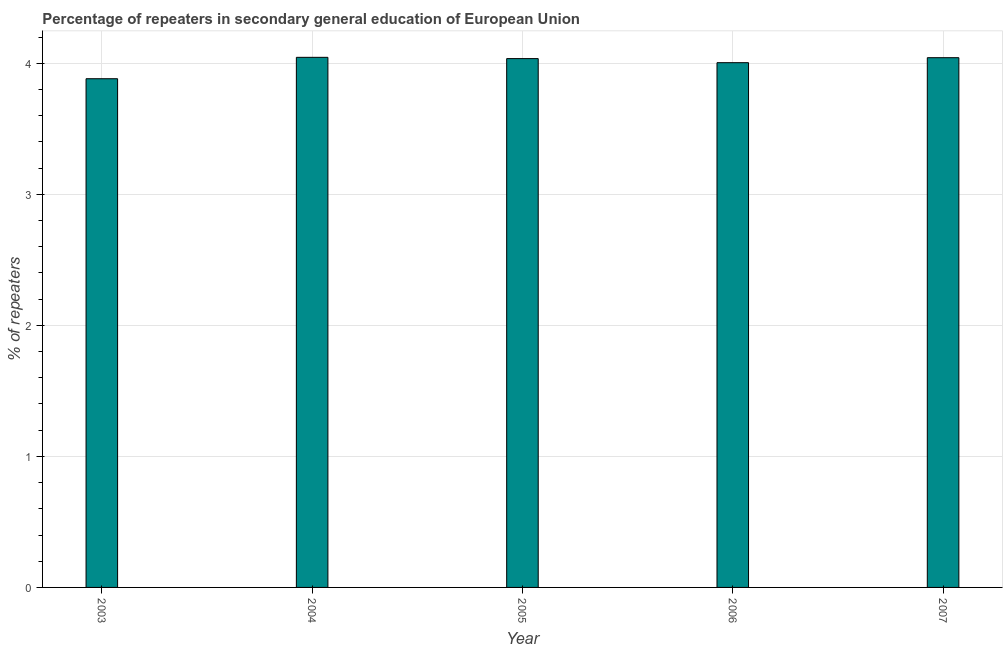What is the title of the graph?
Your answer should be compact. Percentage of repeaters in secondary general education of European Union. What is the label or title of the Y-axis?
Provide a succinct answer. % of repeaters. What is the percentage of repeaters in 2005?
Ensure brevity in your answer.  4.04. Across all years, what is the maximum percentage of repeaters?
Provide a succinct answer. 4.05. Across all years, what is the minimum percentage of repeaters?
Make the answer very short. 3.88. What is the sum of the percentage of repeaters?
Your answer should be very brief. 20.01. What is the difference between the percentage of repeaters in 2004 and 2007?
Offer a terse response. 0. What is the average percentage of repeaters per year?
Offer a very short reply. 4. What is the median percentage of repeaters?
Keep it short and to the point. 4.04. In how many years, is the percentage of repeaters greater than 0.4 %?
Your answer should be very brief. 5. Do a majority of the years between 2006 and 2004 (inclusive) have percentage of repeaters greater than 1.2 %?
Provide a succinct answer. Yes. What is the ratio of the percentage of repeaters in 2003 to that in 2005?
Offer a terse response. 0.96. What is the difference between the highest and the second highest percentage of repeaters?
Provide a short and direct response. 0. What is the difference between the highest and the lowest percentage of repeaters?
Provide a succinct answer. 0.16. How many bars are there?
Ensure brevity in your answer.  5. Are all the bars in the graph horizontal?
Offer a terse response. No. What is the % of repeaters in 2003?
Your response must be concise. 3.88. What is the % of repeaters of 2004?
Provide a short and direct response. 4.05. What is the % of repeaters of 2005?
Offer a terse response. 4.04. What is the % of repeaters of 2006?
Offer a terse response. 4. What is the % of repeaters of 2007?
Keep it short and to the point. 4.04. What is the difference between the % of repeaters in 2003 and 2004?
Keep it short and to the point. -0.16. What is the difference between the % of repeaters in 2003 and 2005?
Provide a short and direct response. -0.15. What is the difference between the % of repeaters in 2003 and 2006?
Offer a terse response. -0.12. What is the difference between the % of repeaters in 2003 and 2007?
Your response must be concise. -0.16. What is the difference between the % of repeaters in 2004 and 2005?
Your answer should be compact. 0.01. What is the difference between the % of repeaters in 2004 and 2006?
Offer a terse response. 0.04. What is the difference between the % of repeaters in 2004 and 2007?
Give a very brief answer. 0. What is the difference between the % of repeaters in 2005 and 2006?
Keep it short and to the point. 0.03. What is the difference between the % of repeaters in 2005 and 2007?
Offer a very short reply. -0.01. What is the difference between the % of repeaters in 2006 and 2007?
Offer a terse response. -0.04. What is the ratio of the % of repeaters in 2003 to that in 2004?
Ensure brevity in your answer.  0.96. What is the ratio of the % of repeaters in 2003 to that in 2006?
Ensure brevity in your answer.  0.97. What is the ratio of the % of repeaters in 2003 to that in 2007?
Give a very brief answer. 0.96. What is the ratio of the % of repeaters in 2004 to that in 2005?
Provide a short and direct response. 1. What is the ratio of the % of repeaters in 2004 to that in 2007?
Provide a succinct answer. 1. What is the ratio of the % of repeaters in 2005 to that in 2007?
Ensure brevity in your answer.  1. 